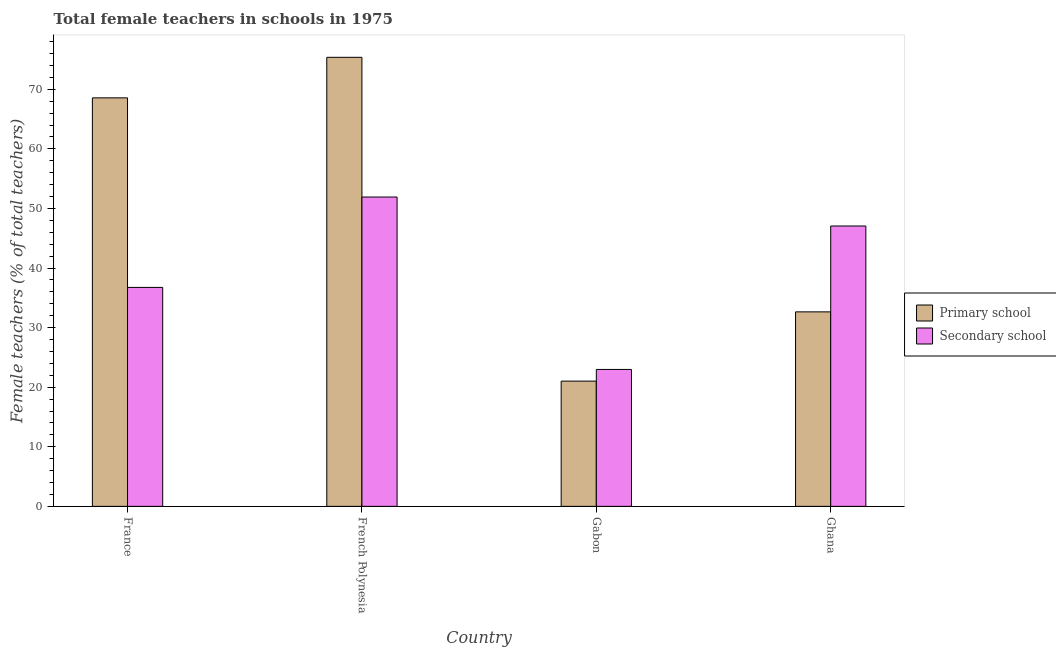How many different coloured bars are there?
Provide a succinct answer. 2. Are the number of bars per tick equal to the number of legend labels?
Your answer should be very brief. Yes. Are the number of bars on each tick of the X-axis equal?
Offer a terse response. Yes. How many bars are there on the 4th tick from the right?
Keep it short and to the point. 2. What is the label of the 4th group of bars from the left?
Your answer should be compact. Ghana. What is the percentage of female teachers in primary schools in French Polynesia?
Your answer should be compact. 75.37. Across all countries, what is the maximum percentage of female teachers in primary schools?
Offer a terse response. 75.37. Across all countries, what is the minimum percentage of female teachers in primary schools?
Keep it short and to the point. 21.02. In which country was the percentage of female teachers in secondary schools maximum?
Offer a very short reply. French Polynesia. In which country was the percentage of female teachers in secondary schools minimum?
Keep it short and to the point. Gabon. What is the total percentage of female teachers in primary schools in the graph?
Provide a short and direct response. 197.6. What is the difference between the percentage of female teachers in primary schools in Gabon and that in Ghana?
Make the answer very short. -11.62. What is the difference between the percentage of female teachers in secondary schools in Ghana and the percentage of female teachers in primary schools in Gabon?
Your response must be concise. 26.04. What is the average percentage of female teachers in primary schools per country?
Your response must be concise. 49.4. What is the difference between the percentage of female teachers in primary schools and percentage of female teachers in secondary schools in Ghana?
Offer a very short reply. -14.42. In how many countries, is the percentage of female teachers in primary schools greater than 38 %?
Make the answer very short. 2. What is the ratio of the percentage of female teachers in primary schools in Gabon to that in Ghana?
Your response must be concise. 0.64. Is the percentage of female teachers in primary schools in France less than that in Ghana?
Ensure brevity in your answer.  No. What is the difference between the highest and the second highest percentage of female teachers in primary schools?
Provide a succinct answer. 6.8. What is the difference between the highest and the lowest percentage of female teachers in primary schools?
Make the answer very short. 54.35. In how many countries, is the percentage of female teachers in secondary schools greater than the average percentage of female teachers in secondary schools taken over all countries?
Give a very brief answer. 2. Is the sum of the percentage of female teachers in secondary schools in France and Ghana greater than the maximum percentage of female teachers in primary schools across all countries?
Provide a short and direct response. Yes. What does the 2nd bar from the left in French Polynesia represents?
Ensure brevity in your answer.  Secondary school. What does the 2nd bar from the right in French Polynesia represents?
Your response must be concise. Primary school. Are all the bars in the graph horizontal?
Your response must be concise. No. What is the difference between two consecutive major ticks on the Y-axis?
Your response must be concise. 10. Are the values on the major ticks of Y-axis written in scientific E-notation?
Your response must be concise. No. Does the graph contain any zero values?
Offer a very short reply. No. Does the graph contain grids?
Ensure brevity in your answer.  No. Where does the legend appear in the graph?
Your response must be concise. Center right. How many legend labels are there?
Make the answer very short. 2. How are the legend labels stacked?
Offer a terse response. Vertical. What is the title of the graph?
Your answer should be very brief. Total female teachers in schools in 1975. What is the label or title of the X-axis?
Offer a very short reply. Country. What is the label or title of the Y-axis?
Provide a succinct answer. Female teachers (% of total teachers). What is the Female teachers (% of total teachers) of Primary school in France?
Offer a terse response. 68.57. What is the Female teachers (% of total teachers) in Secondary school in France?
Keep it short and to the point. 36.75. What is the Female teachers (% of total teachers) of Primary school in French Polynesia?
Give a very brief answer. 75.37. What is the Female teachers (% of total teachers) of Secondary school in French Polynesia?
Your answer should be very brief. 51.92. What is the Female teachers (% of total teachers) of Primary school in Gabon?
Give a very brief answer. 21.02. What is the Female teachers (% of total teachers) in Secondary school in Gabon?
Keep it short and to the point. 22.98. What is the Female teachers (% of total teachers) in Primary school in Ghana?
Your answer should be compact. 32.64. What is the Female teachers (% of total teachers) in Secondary school in Ghana?
Give a very brief answer. 47.06. Across all countries, what is the maximum Female teachers (% of total teachers) of Primary school?
Provide a short and direct response. 75.37. Across all countries, what is the maximum Female teachers (% of total teachers) of Secondary school?
Make the answer very short. 51.92. Across all countries, what is the minimum Female teachers (% of total teachers) of Primary school?
Your response must be concise. 21.02. Across all countries, what is the minimum Female teachers (% of total teachers) in Secondary school?
Give a very brief answer. 22.98. What is the total Female teachers (% of total teachers) of Primary school in the graph?
Ensure brevity in your answer.  197.6. What is the total Female teachers (% of total teachers) of Secondary school in the graph?
Offer a terse response. 158.71. What is the difference between the Female teachers (% of total teachers) of Primary school in France and that in French Polynesia?
Your answer should be compact. -6.8. What is the difference between the Female teachers (% of total teachers) in Secondary school in France and that in French Polynesia?
Your answer should be compact. -15.17. What is the difference between the Female teachers (% of total teachers) in Primary school in France and that in Gabon?
Make the answer very short. 47.55. What is the difference between the Female teachers (% of total teachers) in Secondary school in France and that in Gabon?
Provide a short and direct response. 13.77. What is the difference between the Female teachers (% of total teachers) of Primary school in France and that in Ghana?
Offer a very short reply. 35.93. What is the difference between the Female teachers (% of total teachers) in Secondary school in France and that in Ghana?
Keep it short and to the point. -10.31. What is the difference between the Female teachers (% of total teachers) of Primary school in French Polynesia and that in Gabon?
Provide a short and direct response. 54.35. What is the difference between the Female teachers (% of total teachers) of Secondary school in French Polynesia and that in Gabon?
Make the answer very short. 28.94. What is the difference between the Female teachers (% of total teachers) of Primary school in French Polynesia and that in Ghana?
Your response must be concise. 42.73. What is the difference between the Female teachers (% of total teachers) of Secondary school in French Polynesia and that in Ghana?
Provide a short and direct response. 4.86. What is the difference between the Female teachers (% of total teachers) of Primary school in Gabon and that in Ghana?
Give a very brief answer. -11.62. What is the difference between the Female teachers (% of total teachers) of Secondary school in Gabon and that in Ghana?
Your answer should be very brief. -24.08. What is the difference between the Female teachers (% of total teachers) of Primary school in France and the Female teachers (% of total teachers) of Secondary school in French Polynesia?
Give a very brief answer. 16.65. What is the difference between the Female teachers (% of total teachers) in Primary school in France and the Female teachers (% of total teachers) in Secondary school in Gabon?
Give a very brief answer. 45.59. What is the difference between the Female teachers (% of total teachers) of Primary school in France and the Female teachers (% of total teachers) of Secondary school in Ghana?
Offer a very short reply. 21.51. What is the difference between the Female teachers (% of total teachers) in Primary school in French Polynesia and the Female teachers (% of total teachers) in Secondary school in Gabon?
Offer a terse response. 52.39. What is the difference between the Female teachers (% of total teachers) in Primary school in French Polynesia and the Female teachers (% of total teachers) in Secondary school in Ghana?
Ensure brevity in your answer.  28.31. What is the difference between the Female teachers (% of total teachers) of Primary school in Gabon and the Female teachers (% of total teachers) of Secondary school in Ghana?
Provide a short and direct response. -26.04. What is the average Female teachers (% of total teachers) in Primary school per country?
Your response must be concise. 49.4. What is the average Female teachers (% of total teachers) in Secondary school per country?
Give a very brief answer. 39.68. What is the difference between the Female teachers (% of total teachers) in Primary school and Female teachers (% of total teachers) in Secondary school in France?
Your answer should be very brief. 31.82. What is the difference between the Female teachers (% of total teachers) in Primary school and Female teachers (% of total teachers) in Secondary school in French Polynesia?
Keep it short and to the point. 23.45. What is the difference between the Female teachers (% of total teachers) of Primary school and Female teachers (% of total teachers) of Secondary school in Gabon?
Provide a short and direct response. -1.96. What is the difference between the Female teachers (% of total teachers) of Primary school and Female teachers (% of total teachers) of Secondary school in Ghana?
Your answer should be very brief. -14.42. What is the ratio of the Female teachers (% of total teachers) of Primary school in France to that in French Polynesia?
Offer a very short reply. 0.91. What is the ratio of the Female teachers (% of total teachers) in Secondary school in France to that in French Polynesia?
Ensure brevity in your answer.  0.71. What is the ratio of the Female teachers (% of total teachers) of Primary school in France to that in Gabon?
Keep it short and to the point. 3.26. What is the ratio of the Female teachers (% of total teachers) of Secondary school in France to that in Gabon?
Your response must be concise. 1.6. What is the ratio of the Female teachers (% of total teachers) in Primary school in France to that in Ghana?
Ensure brevity in your answer.  2.1. What is the ratio of the Female teachers (% of total teachers) of Secondary school in France to that in Ghana?
Your answer should be compact. 0.78. What is the ratio of the Female teachers (% of total teachers) in Primary school in French Polynesia to that in Gabon?
Give a very brief answer. 3.59. What is the ratio of the Female teachers (% of total teachers) in Secondary school in French Polynesia to that in Gabon?
Offer a very short reply. 2.26. What is the ratio of the Female teachers (% of total teachers) in Primary school in French Polynesia to that in Ghana?
Offer a very short reply. 2.31. What is the ratio of the Female teachers (% of total teachers) in Secondary school in French Polynesia to that in Ghana?
Offer a very short reply. 1.1. What is the ratio of the Female teachers (% of total teachers) of Primary school in Gabon to that in Ghana?
Your answer should be very brief. 0.64. What is the ratio of the Female teachers (% of total teachers) of Secondary school in Gabon to that in Ghana?
Offer a terse response. 0.49. What is the difference between the highest and the second highest Female teachers (% of total teachers) of Primary school?
Your response must be concise. 6.8. What is the difference between the highest and the second highest Female teachers (% of total teachers) in Secondary school?
Provide a short and direct response. 4.86. What is the difference between the highest and the lowest Female teachers (% of total teachers) of Primary school?
Offer a terse response. 54.35. What is the difference between the highest and the lowest Female teachers (% of total teachers) of Secondary school?
Offer a terse response. 28.94. 